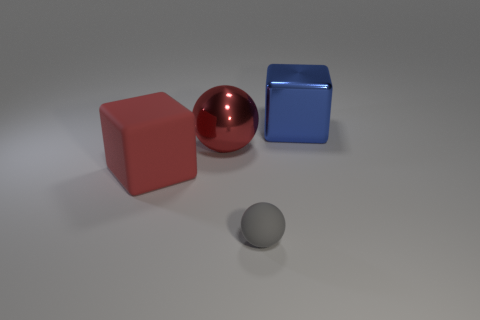Subtract 2 cubes. How many cubes are left? 0 Subtract all purple spheres. Subtract all brown cubes. How many spheres are left? 2 Subtract all cyan spheres. How many blue blocks are left? 1 Subtract all large cyan shiny things. Subtract all gray balls. How many objects are left? 3 Add 3 big rubber cubes. How many big rubber cubes are left? 4 Add 1 small gray things. How many small gray things exist? 2 Add 3 matte things. How many objects exist? 7 Subtract 1 blue cubes. How many objects are left? 3 